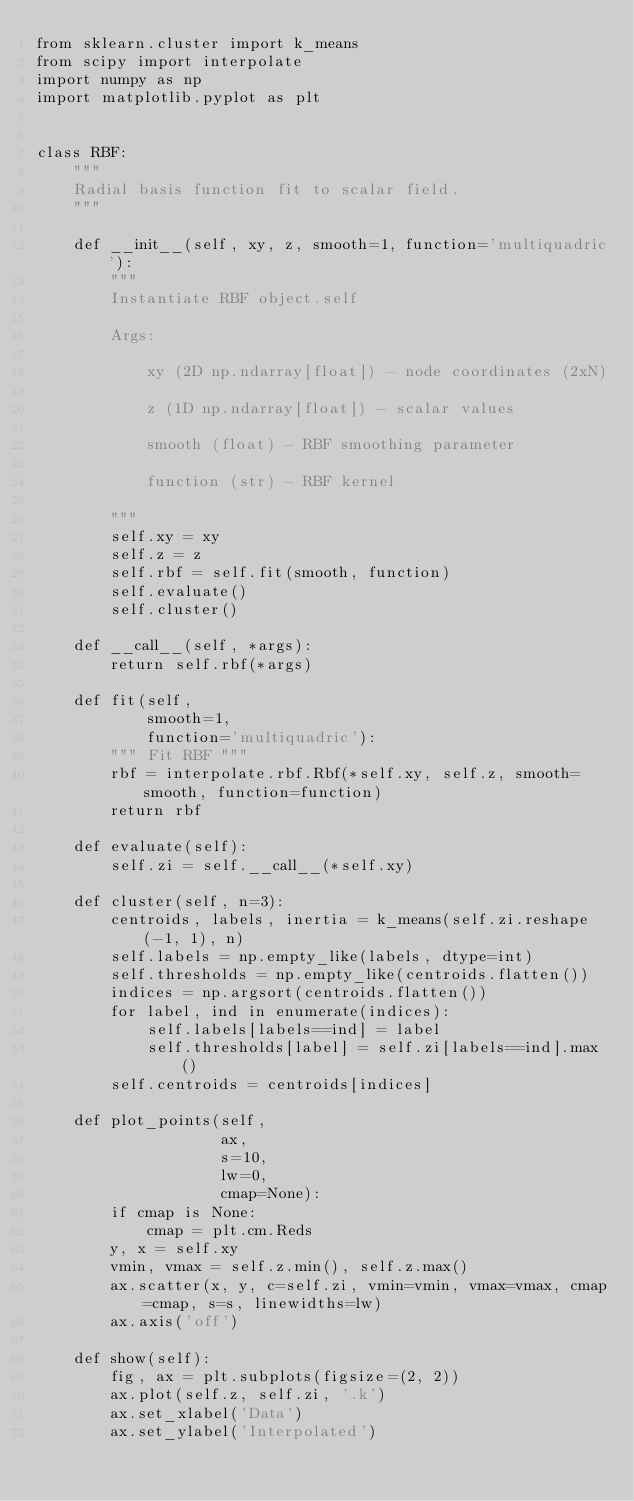Convert code to text. <code><loc_0><loc_0><loc_500><loc_500><_Python_>from sklearn.cluster import k_means
from scipy import interpolate
import numpy as np
import matplotlib.pyplot as plt


class RBF:
    """
    Radial basis function fit to scalar field.
    """

    def __init__(self, xy, z, smooth=1, function='multiquadric'):
        """
        Instantiate RBF object.self

        Args:

            xy (2D np.ndarray[float]) - node coordinates (2xN)

            z (1D np.ndarray[float]) - scalar values

            smooth (float) - RBF smoothing parameter

            function (str) - RBF kernel

        """
        self.xy = xy
        self.z = z
        self.rbf = self.fit(smooth, function)
        self.evaluate()
        self.cluster()

    def __call__(self, *args):
        return self.rbf(*args)

    def fit(self,
            smooth=1,
            function='multiquadric'):
        """ Fit RBF """
        rbf = interpolate.rbf.Rbf(*self.xy, self.z, smooth=smooth, function=function)
        return rbf

    def evaluate(self):
        self.zi = self.__call__(*self.xy)

    def cluster(self, n=3):
        centroids, labels, inertia = k_means(self.zi.reshape(-1, 1), n)
        self.labels = np.empty_like(labels, dtype=int)
        self.thresholds = np.empty_like(centroids.flatten())
        indices = np.argsort(centroids.flatten())
        for label, ind in enumerate(indices):
            self.labels[labels==ind] = label
            self.thresholds[label] = self.zi[labels==ind].max()
        self.centroids = centroids[indices]

    def plot_points(self,
                    ax,
                    s=10,
                    lw=0,
                    cmap=None):
        if cmap is None:
            cmap = plt.cm.Reds
        y, x = self.xy
        vmin, vmax = self.z.min(), self.z.max()
        ax.scatter(x, y, c=self.zi, vmin=vmin, vmax=vmax, cmap=cmap, s=s, linewidths=lw)
        ax.axis('off')

    def show(self):
        fig, ax = plt.subplots(figsize=(2, 2))
        ax.plot(self.z, self.zi, '.k')
        ax.set_xlabel('Data')
        ax.set_ylabel('Interpolated')
</code> 